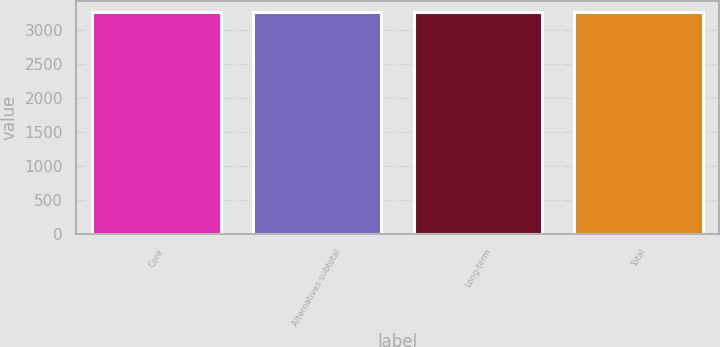Convert chart. <chart><loc_0><loc_0><loc_500><loc_500><bar_chart><fcel>Core<fcel>Alternatives subtotal<fcel>Long-term<fcel>Total<nl><fcel>3264<fcel>3264.1<fcel>3264.2<fcel>3264.3<nl></chart> 